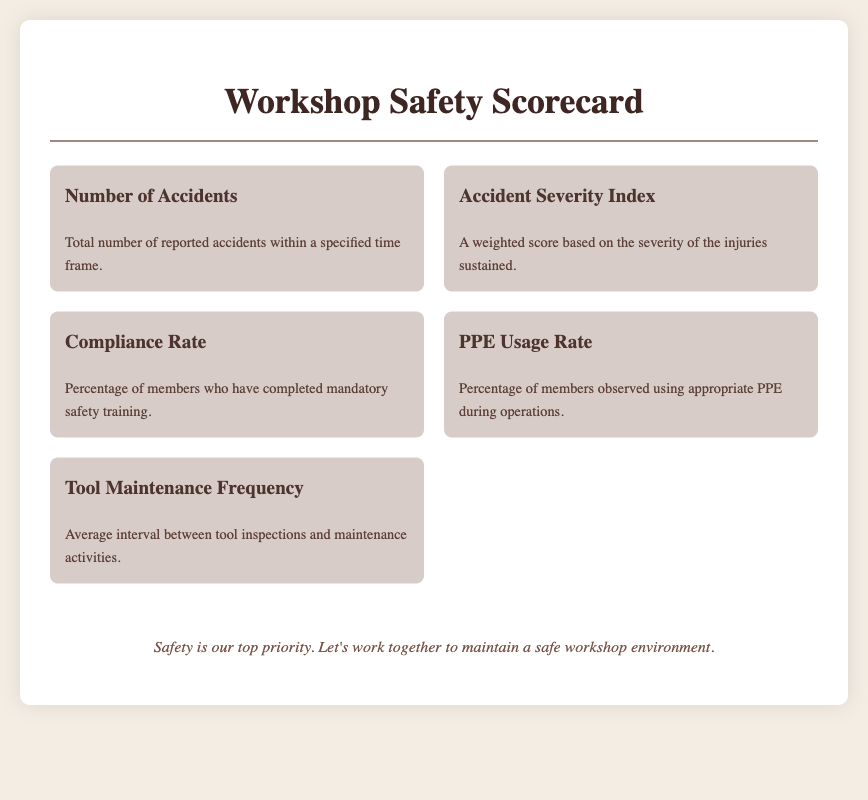What is the total number of reported accidents? The document states that it provides the total number of reported accidents within a specified time frame, categorized under the "Number of Accidents" metric.
Answer: Number of Accidents What does the Accident Severity Index represent? The Accident Severity Index gives a weighted score based on the severity of the injuries sustained, as described in the "Accident Severity Index" metric.
Answer: A weighted score What is the Compliance Rate? The Compliance Rate is defined as the percentage of members who have completed mandatory safety training, outlined in the "Compliance Rate" section.
Answer: Percentage of members What percentage of members use appropriate PPE? The PPE Usage Rate indicates the percentage of members observed using appropriate PPE during operations, according to the respective metric.
Answer: PPE Usage Rate How often are tools inspected? The Tool Maintenance Frequency metric specifies the average interval between tool inspections and maintenance activities.
Answer: Average interval What is the primary focus of the workshop? The document concludes with a footer emphasizing the importance of safety in the workshop environment.
Answer: Safety What type of report is this document classified as? This document is classified as a Scorecard, specifically targeting workshop safety and incident reporting as indicated by the title.
Answer: Scorecard Which metric focuses on training compliance? The metric focused on training compliance is the Compliance Rate, which measures safety training completion among members.
Answer: Compliance Rate 